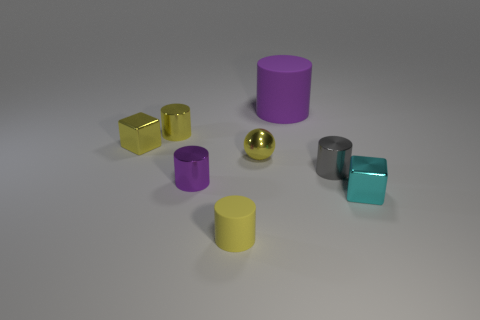Is there another small metallic sphere of the same color as the metallic sphere?
Keep it short and to the point. No. How many objects are either tiny cubes that are on the left side of the yellow metallic sphere or purple objects that are to the left of the large purple object?
Your answer should be very brief. 2. Is the ball the same color as the small matte thing?
Provide a succinct answer. Yes. What is the material of the cube that is the same color as the sphere?
Provide a succinct answer. Metal. Are there fewer gray shiny things in front of the large matte cylinder than objects that are behind the purple shiny thing?
Ensure brevity in your answer.  Yes. Does the gray object have the same material as the tiny cyan block?
Your answer should be very brief. Yes. There is a cylinder that is both on the right side of the yellow rubber cylinder and left of the small gray object; how big is it?
Make the answer very short. Large. There is a purple metal thing that is the same size as the yellow shiny cylinder; what shape is it?
Offer a very short reply. Cylinder. What is the material of the yellow cylinder behind the small metal cube that is right of the purple cylinder that is right of the small purple cylinder?
Give a very brief answer. Metal. Do the purple object that is in front of the yellow metallic block and the matte thing that is on the left side of the big matte thing have the same shape?
Provide a short and direct response. Yes. 